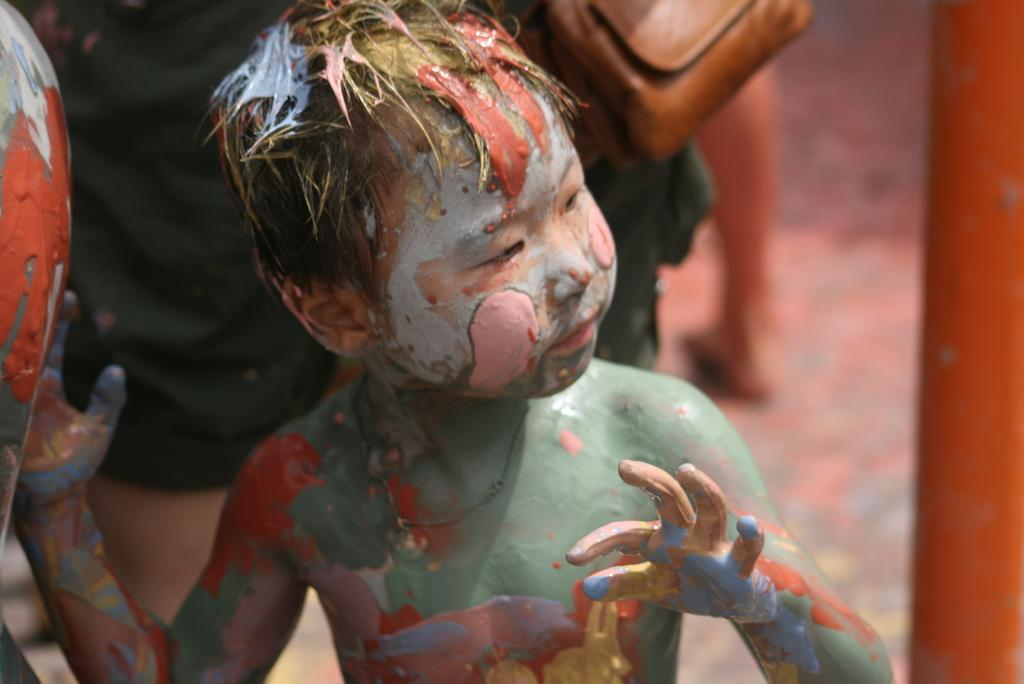Who is the main subject in the image? There is a boy in the image. What is the boy's appearance in the image? The boy is covered in paint. Can you describe the background of the image? The background of the image is blurry. What type of hat is the boy wearing in the image? There is no hat visible in the image; the boy is covered in paint. 